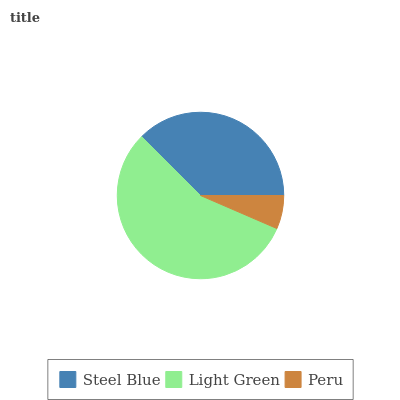Is Peru the minimum?
Answer yes or no. Yes. Is Light Green the maximum?
Answer yes or no. Yes. Is Light Green the minimum?
Answer yes or no. No. Is Peru the maximum?
Answer yes or no. No. Is Light Green greater than Peru?
Answer yes or no. Yes. Is Peru less than Light Green?
Answer yes or no. Yes. Is Peru greater than Light Green?
Answer yes or no. No. Is Light Green less than Peru?
Answer yes or no. No. Is Steel Blue the high median?
Answer yes or no. Yes. Is Steel Blue the low median?
Answer yes or no. Yes. Is Peru the high median?
Answer yes or no. No. Is Light Green the low median?
Answer yes or no. No. 